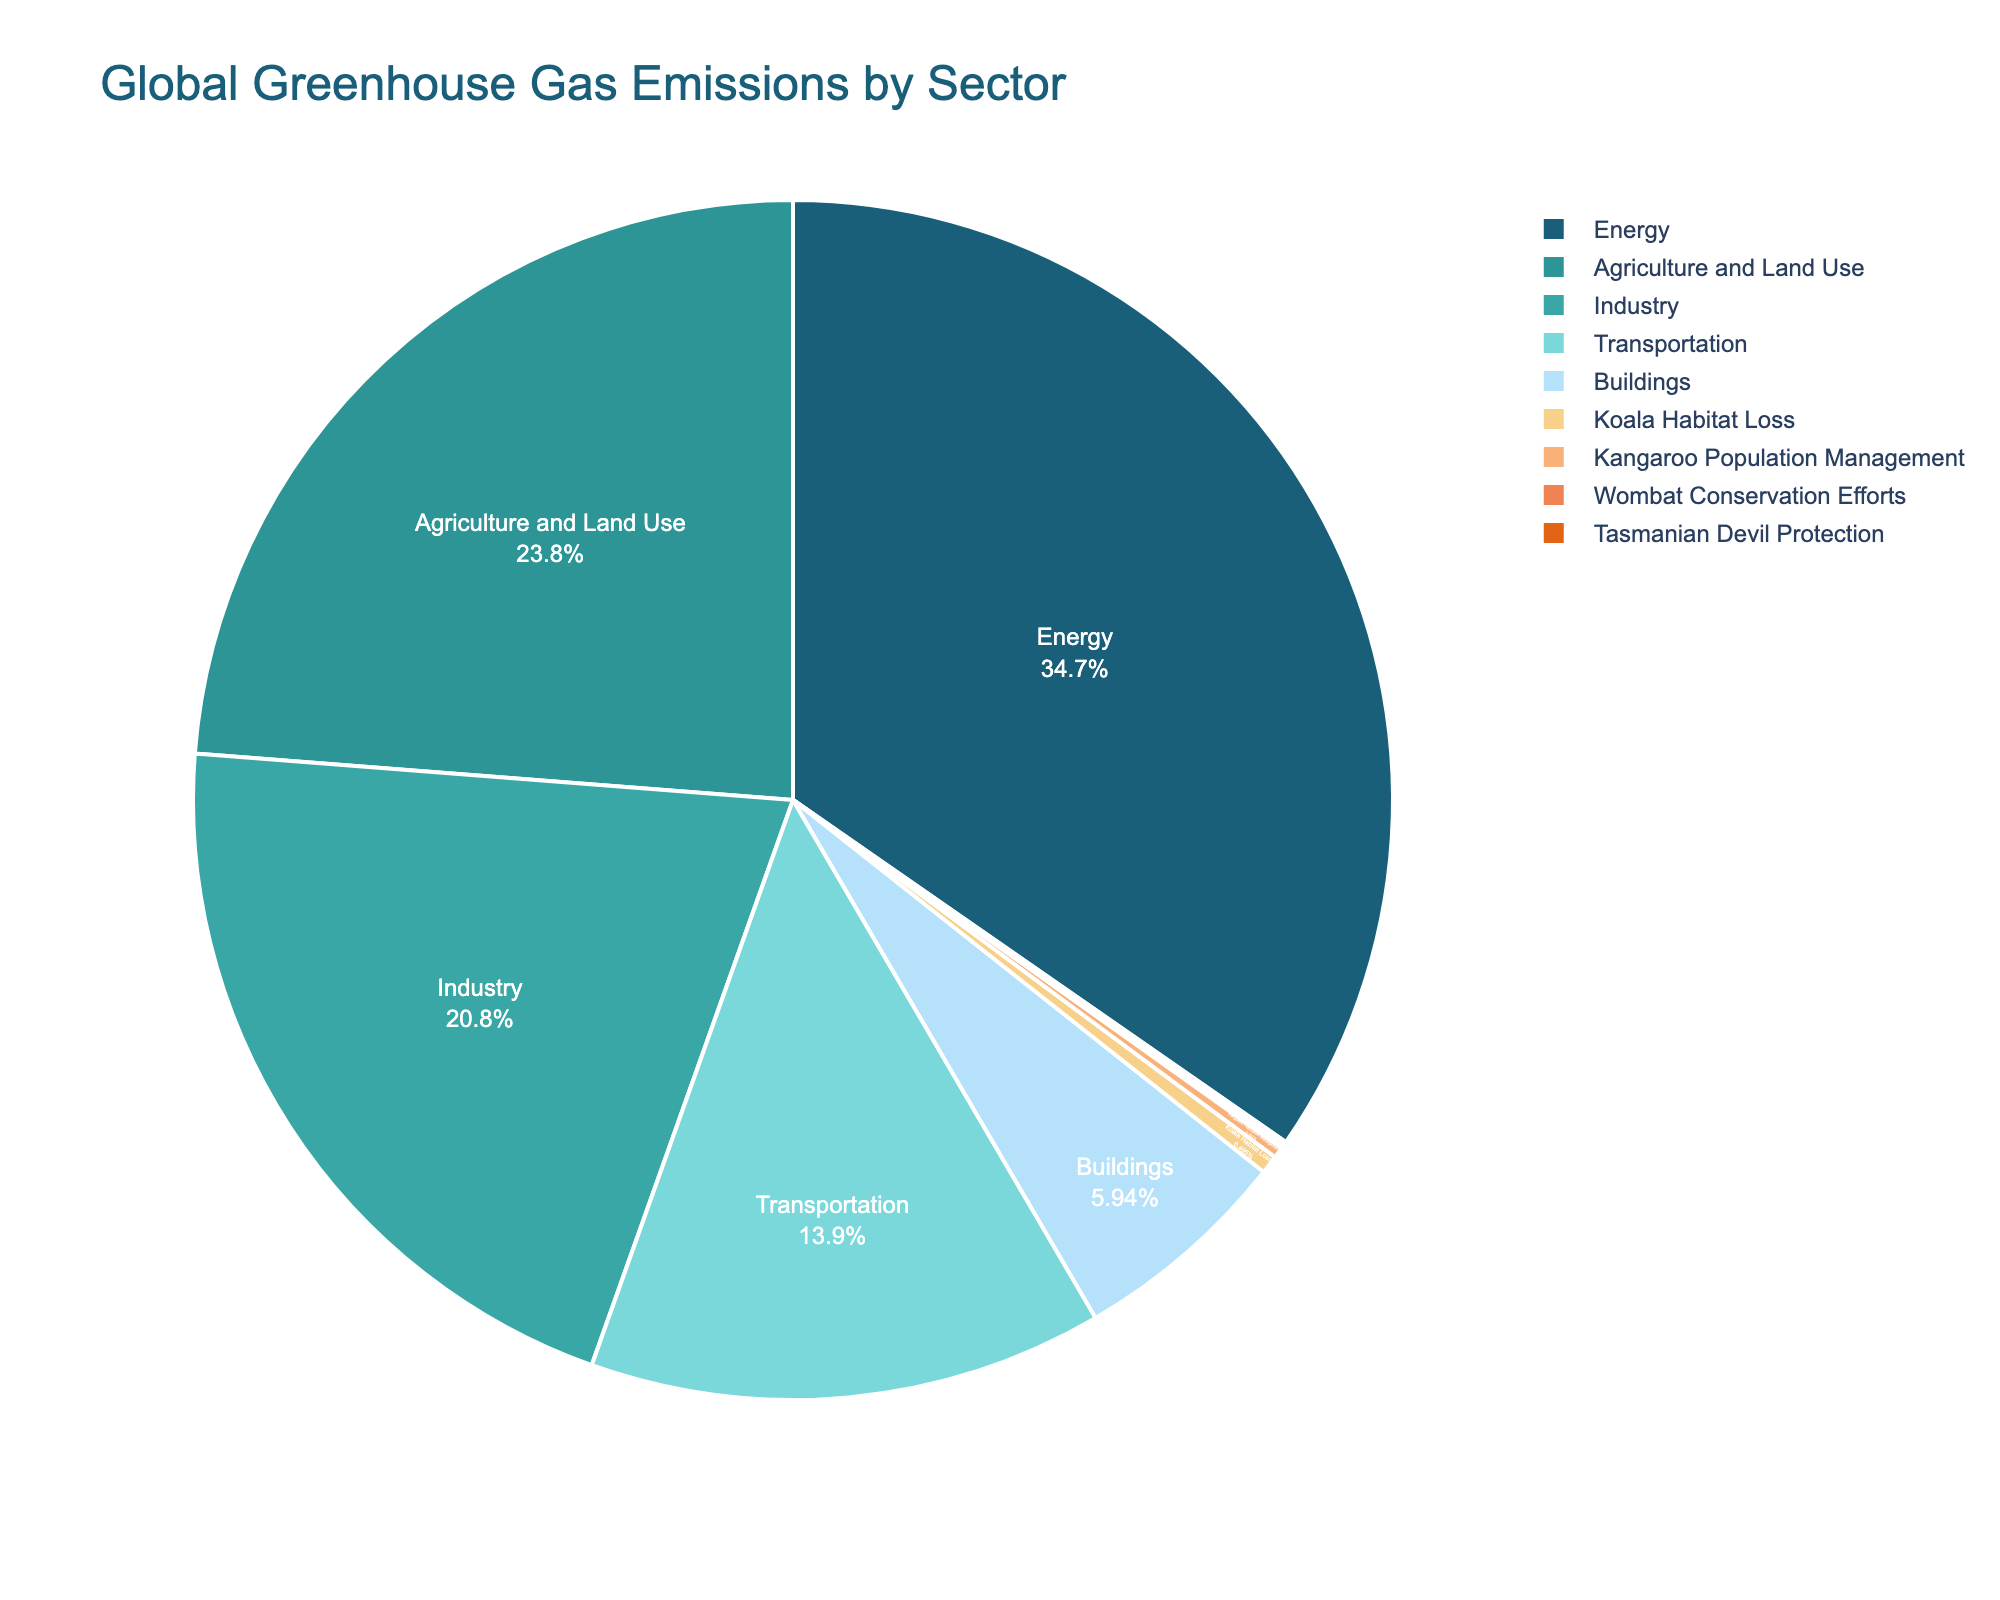What sector contributes the highest percentage to global greenhouse gas emissions? Identify the largest segment in the pie chart. The Energy sector has the largest portion.
Answer: Energy How many times more is the percentage of global greenhouse gas emissions from the Energy sector compared to the Tasmanian Devil Protection? Divide the percentage of emissions from the Energy sector by that of the Tasmanian Devil Protection. \( 35.0 \div 0.1 = 350 \)
Answer: 350 What is the combined percentage contribution of Koala Habitat Loss, Kangaroo Population Management, and Wombat Conservation Efforts? Sum the percentages of Koala Habitat Loss, Kangaroo Population Management, and Wombat Conservation Efforts. \( 0.5 + 0.3 + 0.1 = 0.9 \)
Answer: 0.9% Which sector has a higher percentage contribution, Industry or Agriculture and Land Use? Compare the percentage contributions of the Industry sector and the Agriculture and Land Use sector. Industry: 21.0%, Agriculture and Land Use: 24.0%. Agriculture and Land Use is higher.
Answer: Agriculture and Land Use What is the difference in percentage between Transportation and Buildings sectors? Subtract the percentage of the Buildings sector from the Transportation sector. \( 14.0 - 6.0 = 8 \)
Answer: 8 Which sector has the smallest contribution to global greenhouse gas emissions? Find the smallest segment in the pie chart. The Tasmanian Devil Protection and Wombat Conservation Efforts both have the smallest values at 0.1%.
Answer: Tasmanian Devil Protection / Wombat Conservation Efforts What is the total percentage contribution of the top three sectors? Sum the percentages of Energy, Agriculture and Land Use, and Industry sectors. \( 35.0 + 24.0 + 21.0 = 80.0 \)
Answer: 80.0% Is the percentage contribution of the Energy sector more than twice that of the Transportation sector? Calculate twice the percentage of the Transportation sector and compare it to the Energy sector. \( 2 \times 14.0 = 28.0 \). The Energy sector is 35.0%, which is more.
Answer: Yes 